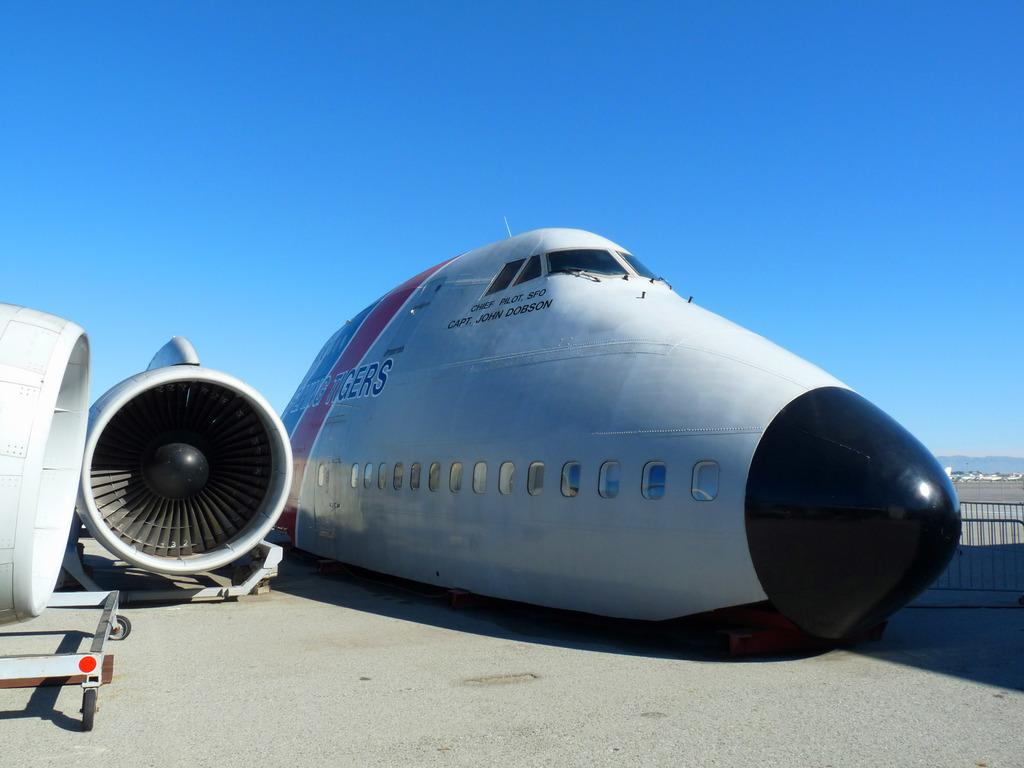What type of object is depicted in the image? There are parts of an aircraft in the image. How many dolls are present in the image, and what is their level of shame? There are no dolls present in the image, and therefore, there is no level of shame to be determined. 